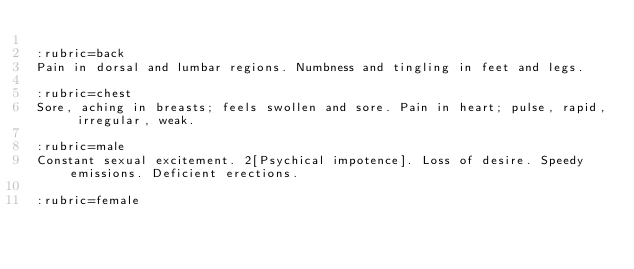Convert code to text. <code><loc_0><loc_0><loc_500><loc_500><_ObjectiveC_>
:rubric=back
Pain in dorsal and lumbar regions. Numbness and tingling in feet and legs.

:rubric=chest
Sore, aching in breasts; feels swollen and sore. Pain in heart; pulse, rapid, irregular, weak.

:rubric=male
Constant sexual excitement. 2[Psychical impotence]. Loss of desire. Speedy emissions. Deficient erections.

:rubric=female</code> 